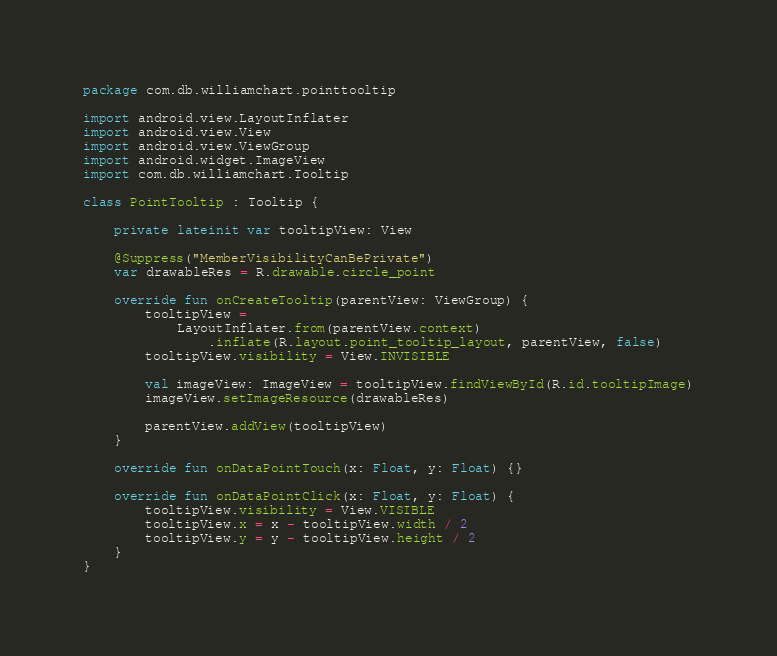<code> <loc_0><loc_0><loc_500><loc_500><_Kotlin_>package com.db.williamchart.pointtooltip

import android.view.LayoutInflater
import android.view.View
import android.view.ViewGroup
import android.widget.ImageView
import com.db.williamchart.Tooltip

class PointTooltip : Tooltip {

    private lateinit var tooltipView: View

    @Suppress("MemberVisibilityCanBePrivate")
    var drawableRes = R.drawable.circle_point

    override fun onCreateTooltip(parentView: ViewGroup) {
        tooltipView =
            LayoutInflater.from(parentView.context)
                .inflate(R.layout.point_tooltip_layout, parentView, false)
        tooltipView.visibility = View.INVISIBLE

        val imageView: ImageView = tooltipView.findViewById(R.id.tooltipImage)
        imageView.setImageResource(drawableRes)

        parentView.addView(tooltipView)
    }

    override fun onDataPointTouch(x: Float, y: Float) {}

    override fun onDataPointClick(x: Float, y: Float) {
        tooltipView.visibility = View.VISIBLE
        tooltipView.x = x - tooltipView.width / 2
        tooltipView.y = y - tooltipView.height / 2
    }
}
</code> 